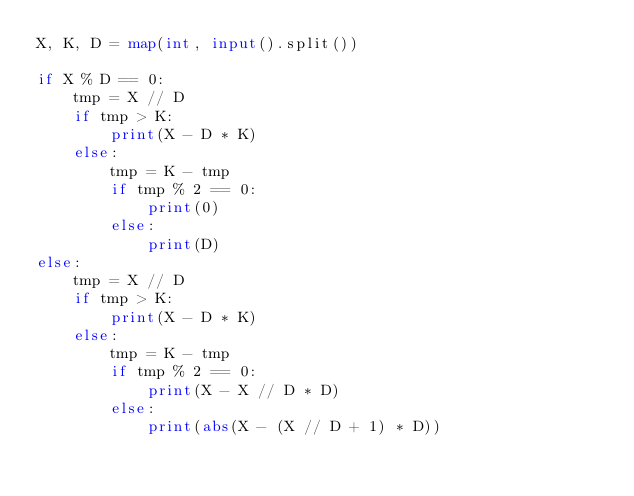<code> <loc_0><loc_0><loc_500><loc_500><_Python_>X, K, D = map(int, input().split())

if X % D == 0:
    tmp = X // D
    if tmp > K:
        print(X - D * K)
    else:
        tmp = K - tmp
        if tmp % 2 == 0:
            print(0)
        else:
            print(D)
else:
    tmp = X // D
    if tmp > K:
        print(X - D * K)
    else:
        tmp = K - tmp
        if tmp % 2 == 0:
            print(X - X // D * D)
        else:
            print(abs(X - (X // D + 1) * D))</code> 